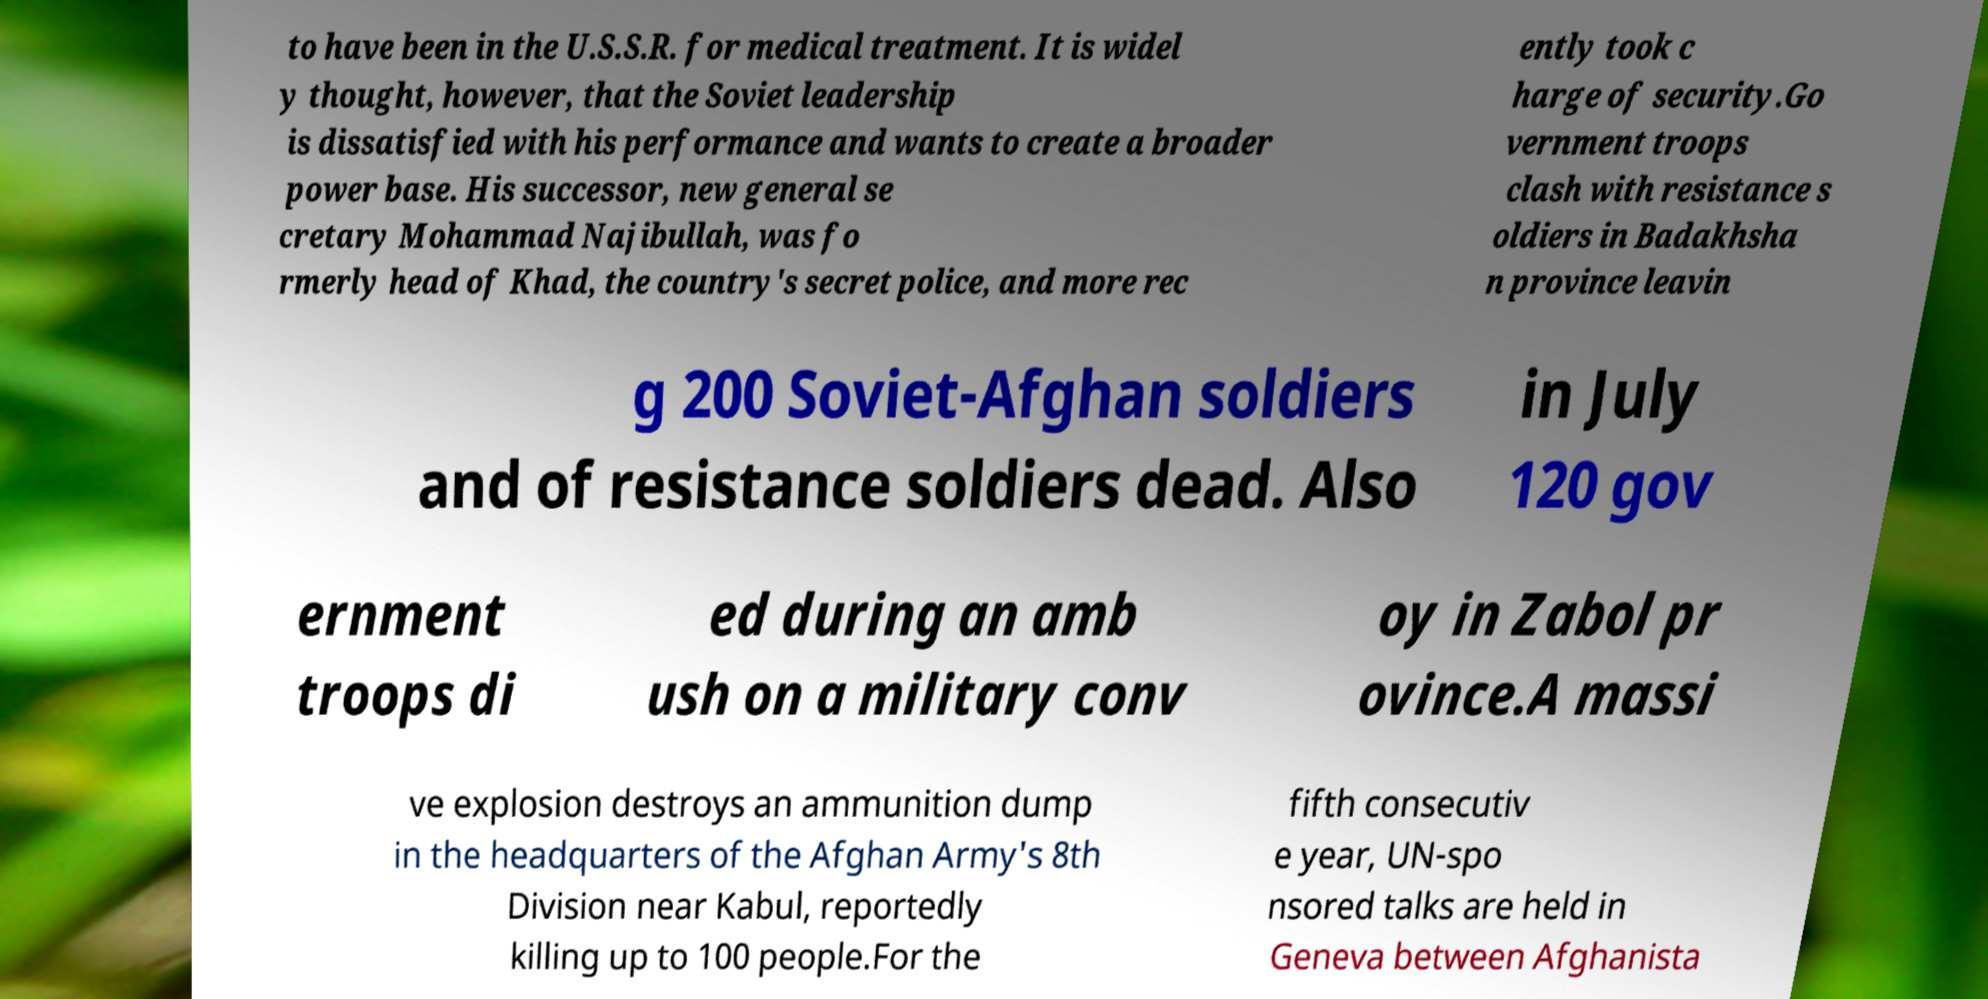Please read and relay the text visible in this image. What does it say? to have been in the U.S.S.R. for medical treatment. It is widel y thought, however, that the Soviet leadership is dissatisfied with his performance and wants to create a broader power base. His successor, new general se cretary Mohammad Najibullah, was fo rmerly head of Khad, the country's secret police, and more rec ently took c harge of security.Go vernment troops clash with resistance s oldiers in Badakhsha n province leavin g 200 Soviet-Afghan soldiers and of resistance soldiers dead. Also in July 120 gov ernment troops di ed during an amb ush on a military conv oy in Zabol pr ovince.A massi ve explosion destroys an ammunition dump in the headquarters of the Afghan Army's 8th Division near Kabul, reportedly killing up to 100 people.For the fifth consecutiv e year, UN-spo nsored talks are held in Geneva between Afghanista 